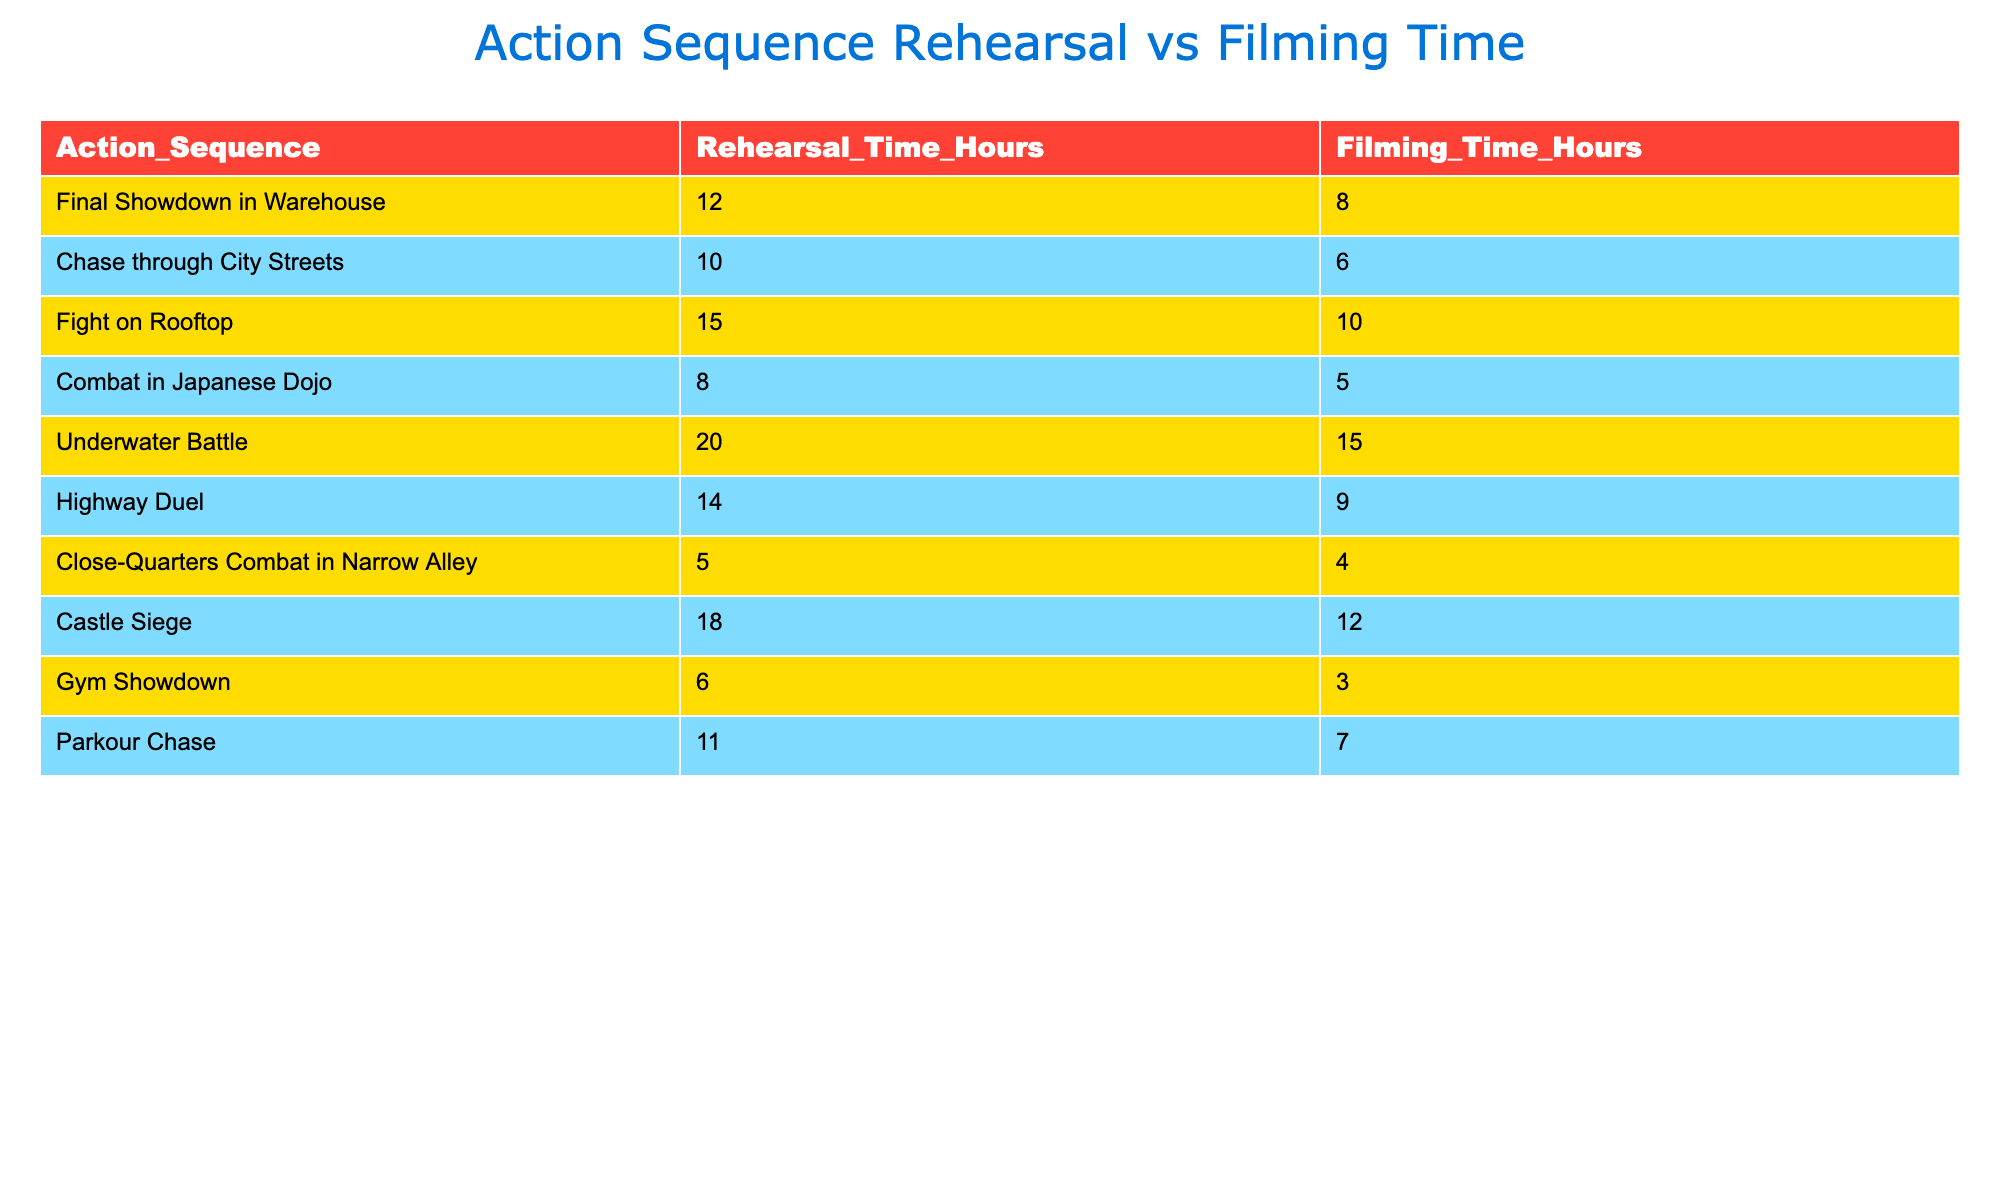What action sequence had the highest rehearsal time? By examining the "Rehearsal_Time_Hours" column, we see that "Underwater Battle" has the highest value of 20 hours.
Answer: Underwater Battle What is the total filming time for all action sequences? To find the total filming time, we add together all values from the "Filming_Time_Hours" column: 8 + 6 + 10 + 5 + 15 + 9 + 4 + 12 + 3 + 7 = 79.
Answer: 79 Is the rehearsal time for "Chase through City Streets" greater than the filming time for "Highway Duel"? Looking at the values, "Chase through City Streets" has a rehearsal time of 10 hours, and "Highway Duel" has a filming time of 9 hours. Since 10 is greater than 9, the statement is true.
Answer: Yes What is the average rehearsal time for all action sequences? To calculate the average, we sum all rehearsal times: 12 + 10 + 15 + 8 + 20 + 14 + 5 + 18 + 6 + 11 = 115. There are 10 sequences, so the average is 115 / 10 = 11.5.
Answer: 11.5 Which action sequence had the least rehearsal time? By inspecting the "Rehearsal_Time_Hours" column, we see that "Close-Quarters Combat in Narrow Alley" has the least rehearsal time of 5 hours.
Answer: Close-Quarters Combat in Narrow Alley What is the difference between the rehearsal time and filming time for "Final Showdown in Warehouse"? The rehearsal time is 12 hours and the filming time is 8 hours. The difference is 12 - 8 = 4 hours.
Answer: 4 hours Are there any action sequences with more rehearsal time than filming time? By comparing the values, we see that all action sequences except "Close-Quarters Combat in Narrow Alley" have more rehearsal hours than filming hours, confirming there are sequences that fit this criterion.
Answer: Yes What is the total rehearsal time for action sequences with filming time less than 10 hours? First, we identify sequences with filming time less than 10 hours: "Chase through City Streets" (10 hours), "Combat in Japanese Dojo" (5 hours), "Gym Showdown" (3 hours), and "Parkour Chase" (7 hours). Their rehearsal times are 10 + 8 + 6 + 11 = 35 hours.
Answer: 35 What is the median filming time for the action sequences? To find the median, we first list the filming times in order: 3, 4, 5, 6, 7, 8, 9, 10, 12, 15. There are 10 values, so the median is the average of the 5th and 6th values, which are 7 and 8. The median is (7 + 8) / 2 = 7.5.
Answer: 7.5 